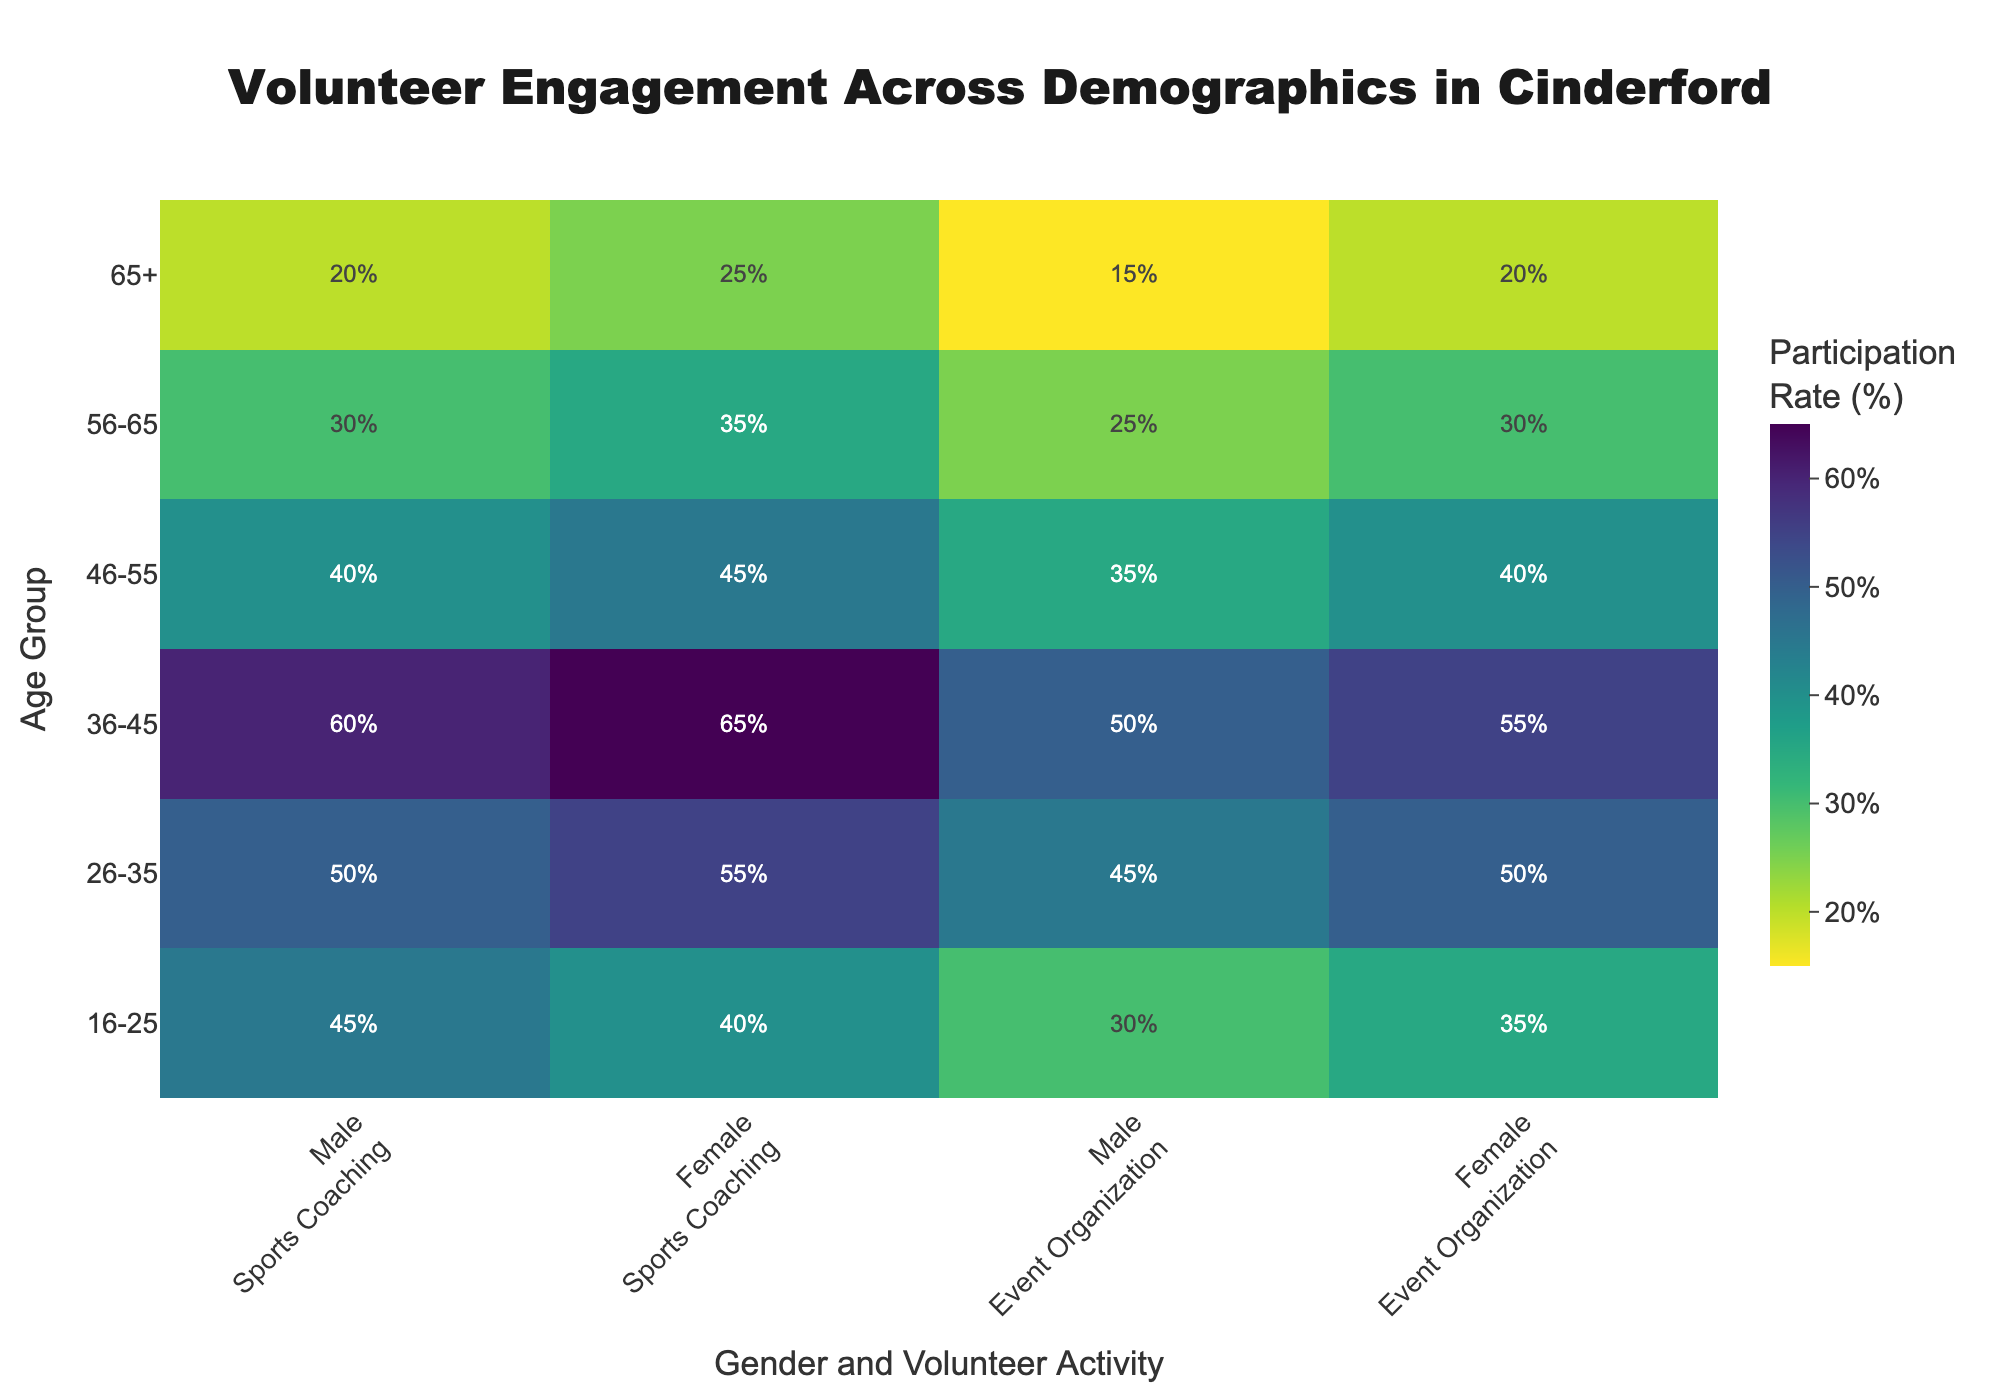What is the participation rate for females aged 26-35 in Sports Coaching? To find this information, locate the row for the age group 26-35 and the column labeled 'Female <br> Sports Coaching'. The value at this intersection is the participation rate.
Answer: 55% Which age group has the highest participation rate in Event Organization? Compare the values under the 'Event Organization' columns for both males and females across all age groups. The highest value is 55% for females aged 36-45.
Answer: 36-45 How does the participation rate in Sports Coaching for males aged 46-55 compare to the rate for females aged 46-55? Find the participation rates for males and females in the 46-55 age group under the 'Sports Coaching' columns. Males have a rate of 40% while females have 45%.
Answer: Females have a higher rate What is the average participation rate for Sports Coaching across all age groups? Sum the participation rates for Sports Coaching for both males and females across all age groups and divide by the total number of rates. (45+40+50+55+60+65+40+45+30+35+20+25)/12 = 485/12 ≈ 40.42
Answer: 40.42% Do males or females aged 16-25 have a higher participation rate in Event Organization? Locate the participation rates for males and females in the age group 16-25 under the 'Event Organization' columns. Males have a rate of 30% and females 35%.
Answer: Females Which activity has a higher participation rate for females aged 65+? Compare the values for females aged 65+ in 'Sports Coaching' and 'Event Organization'. The rates are 25% for Sports Coaching and 20% for Event Organization.
Answer: Sports Coaching What is the difference in participation rates for Event Organization between males aged 36-45 and females aged 36-45? Find the participation rates for Event Organization for males (50%) and females (55%) aged 36-45, then calculate the difference: 55% - 50% = 5%.
Answer: 5% How many age groups have a participation rate of 50% or higher in any activity for males? Identify the age groups where males have a participation rate of 50% or higher in either 'Sports Coaching' or 'Event Organization'. There are three: 26-35 (Sports Coaching), 36-45 (Sports Coaching, Event Organization), and 26-35 (Event Organization).
Answer: 3 Which gender has a higher overall participation rate in Sports Coaching across all age groups? Sum the participation rates for males and females in 'Sports Coaching' across all age groups and compare. Males' total: 45+50+60+40+30+20 = 245, Females' total: 40+55+65+45+35+25 = 265. Females have a higher total rate.
Answer: Females 